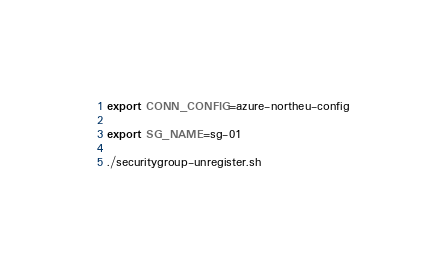<code> <loc_0><loc_0><loc_500><loc_500><_Bash_>export CONN_CONFIG=azure-northeu-config

export SG_NAME=sg-01

./securitygroup-unregister.sh
</code> 